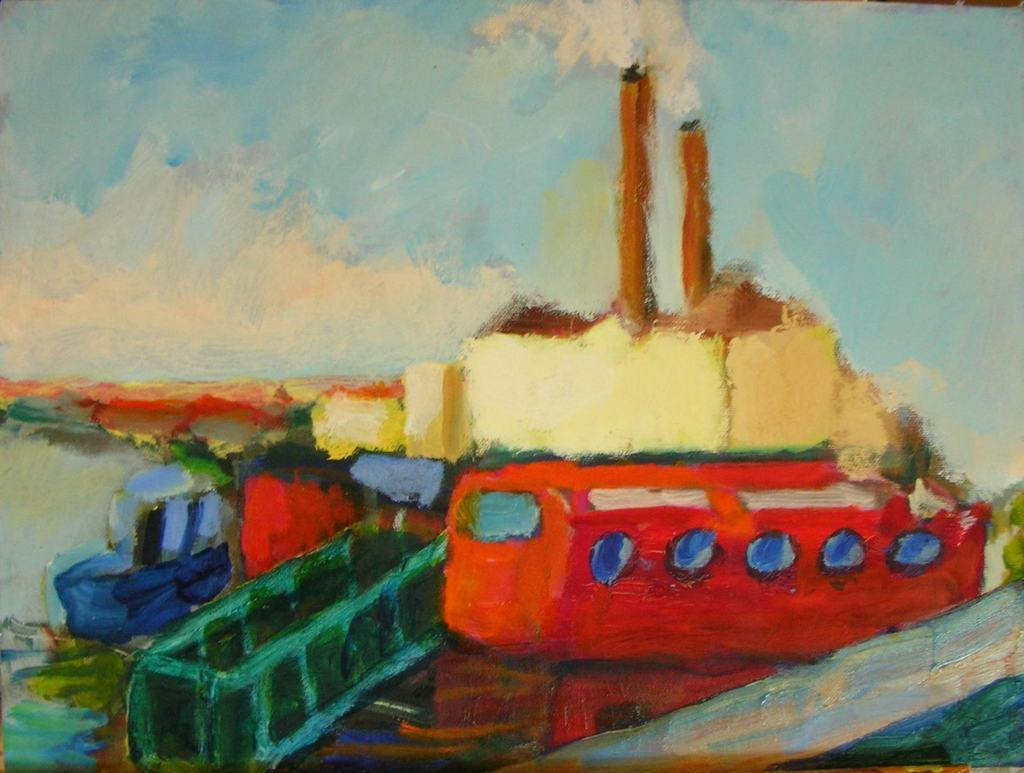What is the main subject of the painting in the image? The painting contains a ship. What else can be seen in the painting besides the ship? The painting contains water, objects, houses, and the sky. Is there any indication of weather conditions in the painting? Yes, there is smoke in the painting, which might suggest a smoky or foggy atmosphere. Is there an animal attending the party in the painting? There is no party depicted in the painting, and therefore no animals or attendees can be observed. 